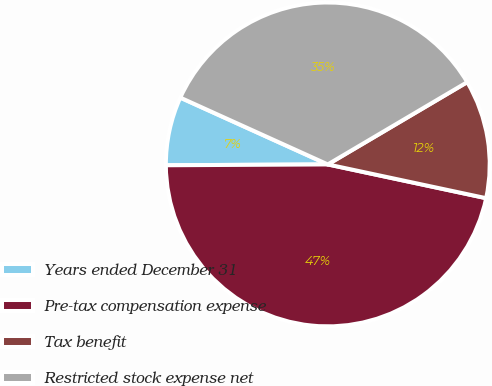Convert chart to OTSL. <chart><loc_0><loc_0><loc_500><loc_500><pie_chart><fcel>Years ended December 31<fcel>Pre-tax compensation expense<fcel>Tax benefit<fcel>Restricted stock expense net<nl><fcel>6.85%<fcel>46.58%<fcel>11.83%<fcel>34.75%<nl></chart> 